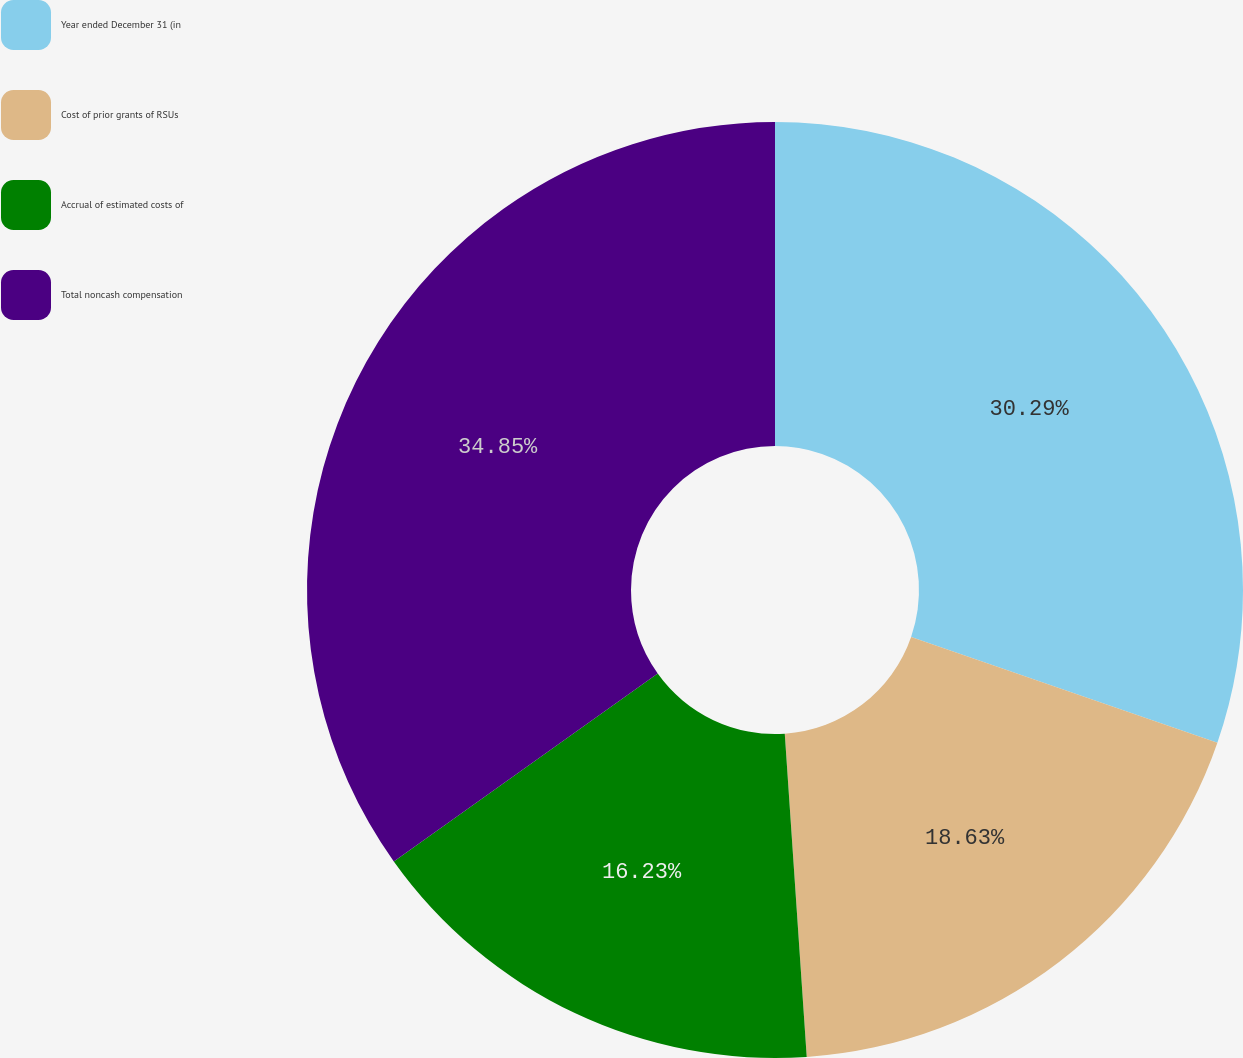Convert chart. <chart><loc_0><loc_0><loc_500><loc_500><pie_chart><fcel>Year ended December 31 (in<fcel>Cost of prior grants of RSUs<fcel>Accrual of estimated costs of<fcel>Total noncash compensation<nl><fcel>30.29%<fcel>18.63%<fcel>16.23%<fcel>34.85%<nl></chart> 